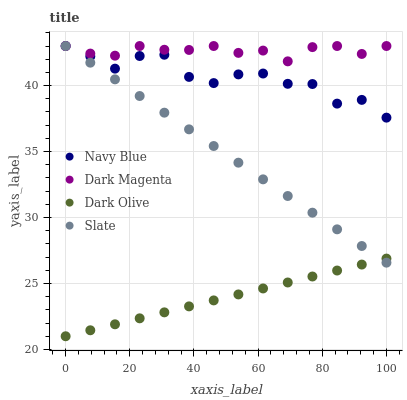Does Dark Olive have the minimum area under the curve?
Answer yes or no. Yes. Does Dark Magenta have the maximum area under the curve?
Answer yes or no. Yes. Does Slate have the minimum area under the curve?
Answer yes or no. No. Does Slate have the maximum area under the curve?
Answer yes or no. No. Is Dark Olive the smoothest?
Answer yes or no. Yes. Is Navy Blue the roughest?
Answer yes or no. Yes. Is Slate the smoothest?
Answer yes or no. No. Is Slate the roughest?
Answer yes or no. No. Does Dark Olive have the lowest value?
Answer yes or no. Yes. Does Slate have the lowest value?
Answer yes or no. No. Does Dark Magenta have the highest value?
Answer yes or no. Yes. Does Dark Olive have the highest value?
Answer yes or no. No. Is Dark Olive less than Dark Magenta?
Answer yes or no. Yes. Is Dark Magenta greater than Dark Olive?
Answer yes or no. Yes. Does Navy Blue intersect Dark Magenta?
Answer yes or no. Yes. Is Navy Blue less than Dark Magenta?
Answer yes or no. No. Is Navy Blue greater than Dark Magenta?
Answer yes or no. No. Does Dark Olive intersect Dark Magenta?
Answer yes or no. No. 